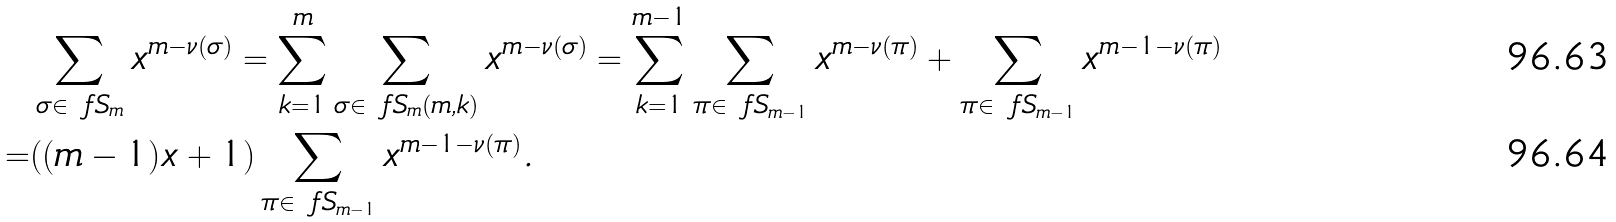Convert formula to latex. <formula><loc_0><loc_0><loc_500><loc_500>& \sum _ { \sigma \in \ f S _ { m } } x ^ { m - \nu ( \sigma ) } = \sum _ { k = 1 } ^ { m } \sum _ { \sigma \in \ f S _ { m } ( m , k ) } x ^ { m - \nu ( \sigma ) } = \sum _ { k = 1 } ^ { m - 1 } \sum _ { \pi \in \ f S _ { m - 1 } } x ^ { m - \nu ( \pi ) } + \sum _ { \pi \in \ f S _ { m - 1 } } x ^ { m - 1 - \nu ( \pi ) } \\ = & ( ( m - 1 ) x + 1 ) \sum _ { \pi \in \ f S _ { m - 1 } } x ^ { m - 1 - \nu ( \pi ) } .</formula> 